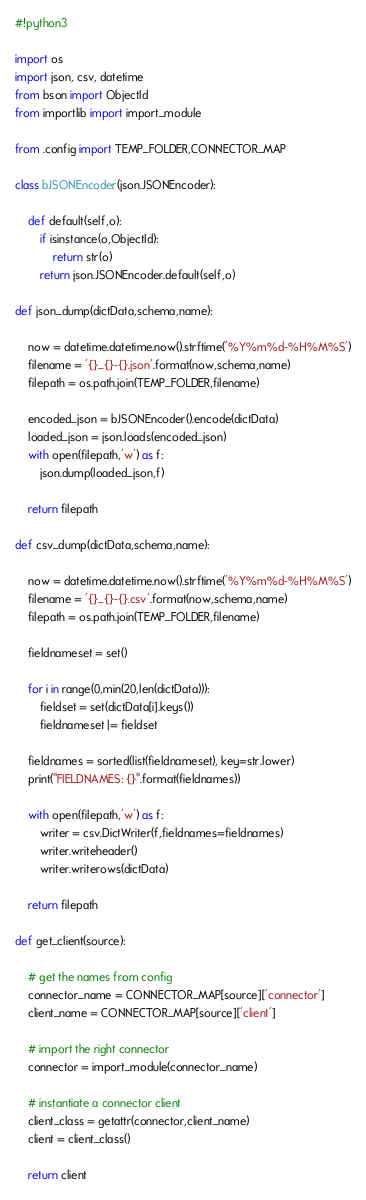Convert code to text. <code><loc_0><loc_0><loc_500><loc_500><_Python_>#!python3

import os
import json, csv, datetime
from bson import ObjectId
from importlib import import_module

from .config import TEMP_FOLDER,CONNECTOR_MAP

class bJSONEncoder(json.JSONEncoder):

    def default(self,o):
        if isinstance(o,ObjectId):
            return str(o)
        return json.JSONEncoder.default(self,o)

def json_dump(dictData,schema,name):

    now = datetime.datetime.now().strftime('%Y%m%d-%H%M%S')
    filename = '{}_{}-{}.json'.format(now,schema,name)
    filepath = os.path.join(TEMP_FOLDER,filename)

    encoded_json = bJSONEncoder().encode(dictData)
    loaded_json = json.loads(encoded_json)
    with open(filepath,'w') as f:
        json.dump(loaded_json,f)

    return filepath

def csv_dump(dictData,schema,name):

    now = datetime.datetime.now().strftime('%Y%m%d-%H%M%S')
    filename = '{}_{}-{}.csv'.format(now,schema,name)
    filepath = os.path.join(TEMP_FOLDER,filename)

    fieldnameset = set()

    for i in range(0,min(20,len(dictData))):
        fieldset = set(dictData[i].keys())
        fieldnameset |= fieldset
    
    fieldnames = sorted(list(fieldnameset), key=str.lower)
    print("FIELDNAMES: {}".format(fieldnames))

    with open(filepath,'w') as f:
        writer = csv.DictWriter(f,fieldnames=fieldnames)
        writer.writeheader()
        writer.writerows(dictData)

    return filepath

def get_client(source):

    # get the names from config
    connector_name = CONNECTOR_MAP[source]['connector']
    client_name = CONNECTOR_MAP[source]['client']

    # import the right connector
    connector = import_module(connector_name)

    # instantiate a connector client
    client_class = getattr(connector,client_name)
    client = client_class()

    return client
</code> 